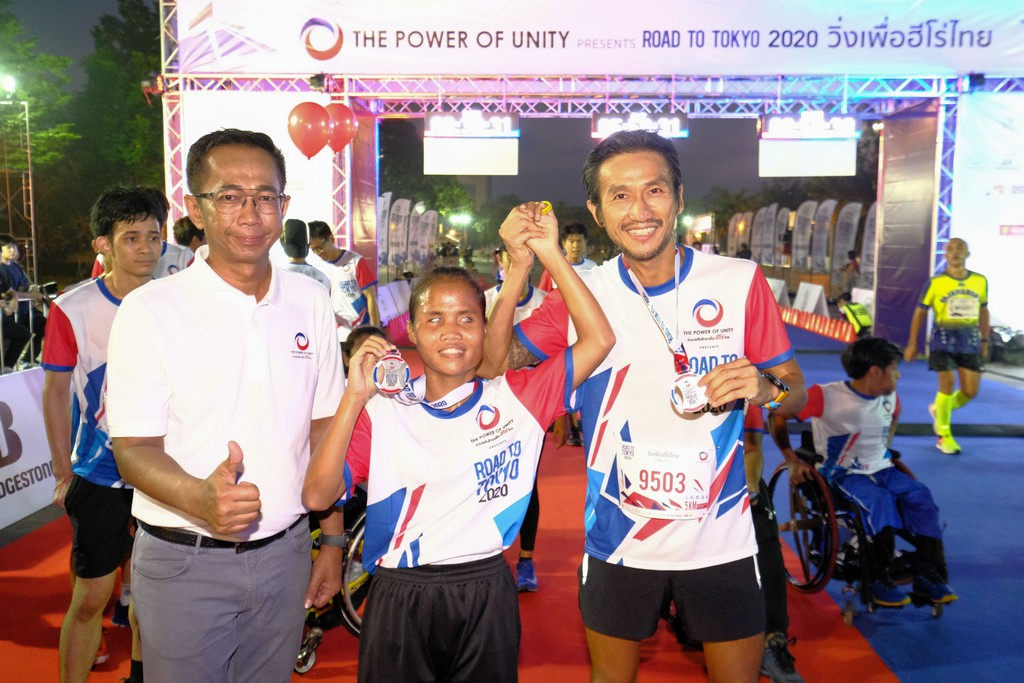Considering the attire and medals of the participants, along with the "ROAD TO TOKYO 2020" banner, what might be the significance of this event and how does it reflect the broader context of the Olympic spirit? The image captures a significant event celebrating the upcoming Tokyo 2020 Olympics, evident from the 'ROAD TO TOKYO 2020' banner. This gathering likely serves to inspire athletes and participants, promoting unity and the Olympic ethos of inclusiveness and perseverance. Featuring a mix of participants, including a wheelchair athlete, it underscores the Olympics' commitment to diversity and the encouragement of all individuals, regardless of physical abilities, to engage in sports. Such events play a crucial role in building anticipation and communal support for the Olympic Games, while also reinforcing the values of sportsmanship and solidarity among participants from diverse backgrounds. 